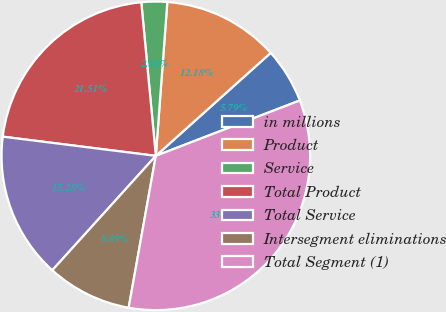Convert chart. <chart><loc_0><loc_0><loc_500><loc_500><pie_chart><fcel>in millions<fcel>Product<fcel>Service<fcel>Total Product<fcel>Total Service<fcel>Intersegment eliminations<fcel>Total Segment (1)<nl><fcel>5.79%<fcel>12.18%<fcel>2.69%<fcel>21.51%<fcel>15.28%<fcel>8.89%<fcel>33.66%<nl></chart> 